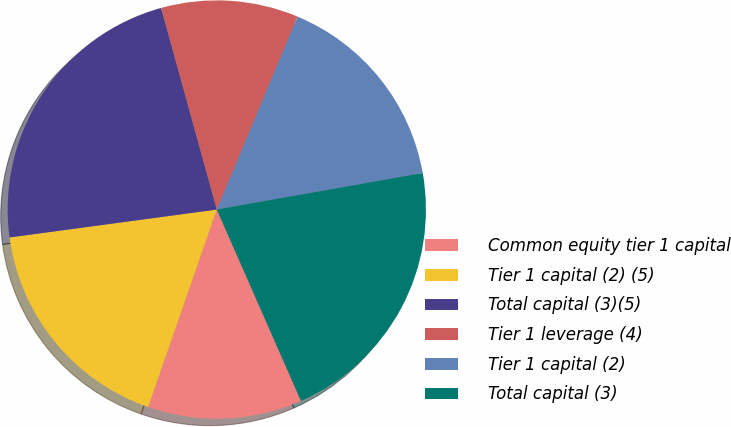Convert chart to OTSL. <chart><loc_0><loc_0><loc_500><loc_500><pie_chart><fcel>Common equity tier 1 capital<fcel>Tier 1 capital (2) (5)<fcel>Total capital (3)(5)<fcel>Tier 1 leverage (4)<fcel>Tier 1 capital (2)<fcel>Total capital (3)<nl><fcel>11.92%<fcel>17.54%<fcel>22.84%<fcel>10.6%<fcel>15.9%<fcel>21.2%<nl></chart> 